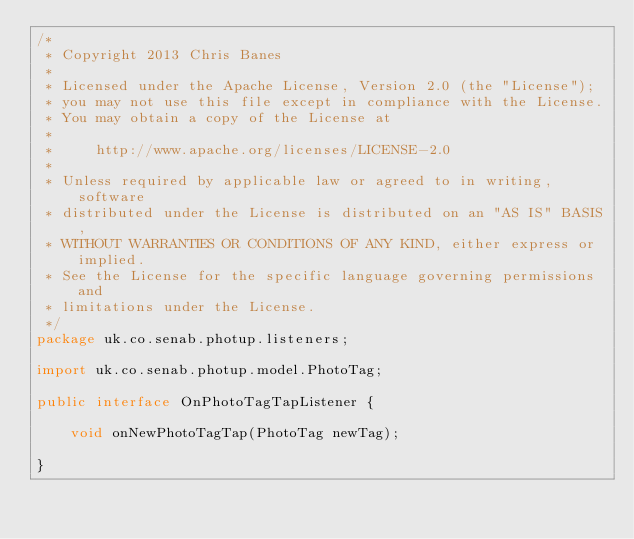<code> <loc_0><loc_0><loc_500><loc_500><_Java_>/*
 * Copyright 2013 Chris Banes
 *
 * Licensed under the Apache License, Version 2.0 (the "License");
 * you may not use this file except in compliance with the License.
 * You may obtain a copy of the License at
 *
 *     http://www.apache.org/licenses/LICENSE-2.0
 *
 * Unless required by applicable law or agreed to in writing, software
 * distributed under the License is distributed on an "AS IS" BASIS,
 * WITHOUT WARRANTIES OR CONDITIONS OF ANY KIND, either express or implied.
 * See the License for the specific language governing permissions and
 * limitations under the License.
 */
package uk.co.senab.photup.listeners;

import uk.co.senab.photup.model.PhotoTag;

public interface OnPhotoTagTapListener {

    void onNewPhotoTagTap(PhotoTag newTag);

}
</code> 